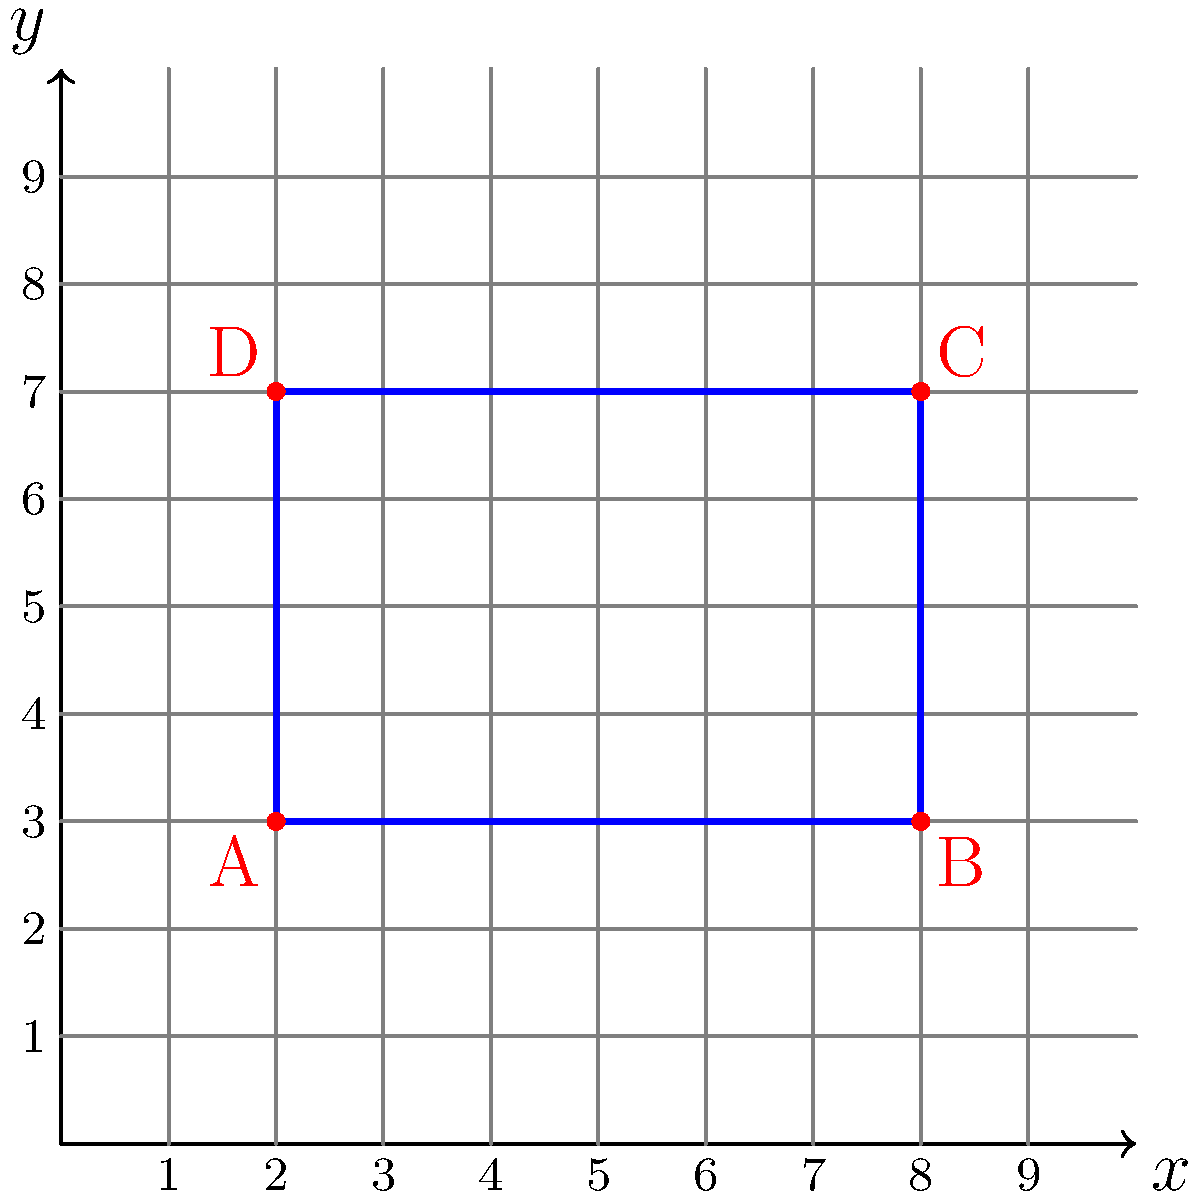You're planning a new dog run for your beloved Chihuahuas in your backyard. The corners of the rectangular run are marked on a coordinate grid, as shown in the diagram. Point A is at (2, 3), B at (8, 3), C at (8, 7), and D at (2, 7). What is the area of this dog run in square units? Let's approach this step-by-step:

1) To find the area of a rectangle, we need its length and width.

2) The length of the rectangle is the distance between points A and B (or D and C).
   We can calculate this using the x-coordinates:
   Length = $8 - 2 = 6$ units

3) The width of the rectangle is the distance between points A and D (or B and C).
   We can calculate this using the y-coordinates:
   Width = $7 - 3 = 4$ units

4) Now that we have the length and width, we can calculate the area:
   Area = Length × Width
   Area = $6 \times 4 = 24$ square units

Therefore, the area of the dog run is 24 square units.
Answer: 24 square units 